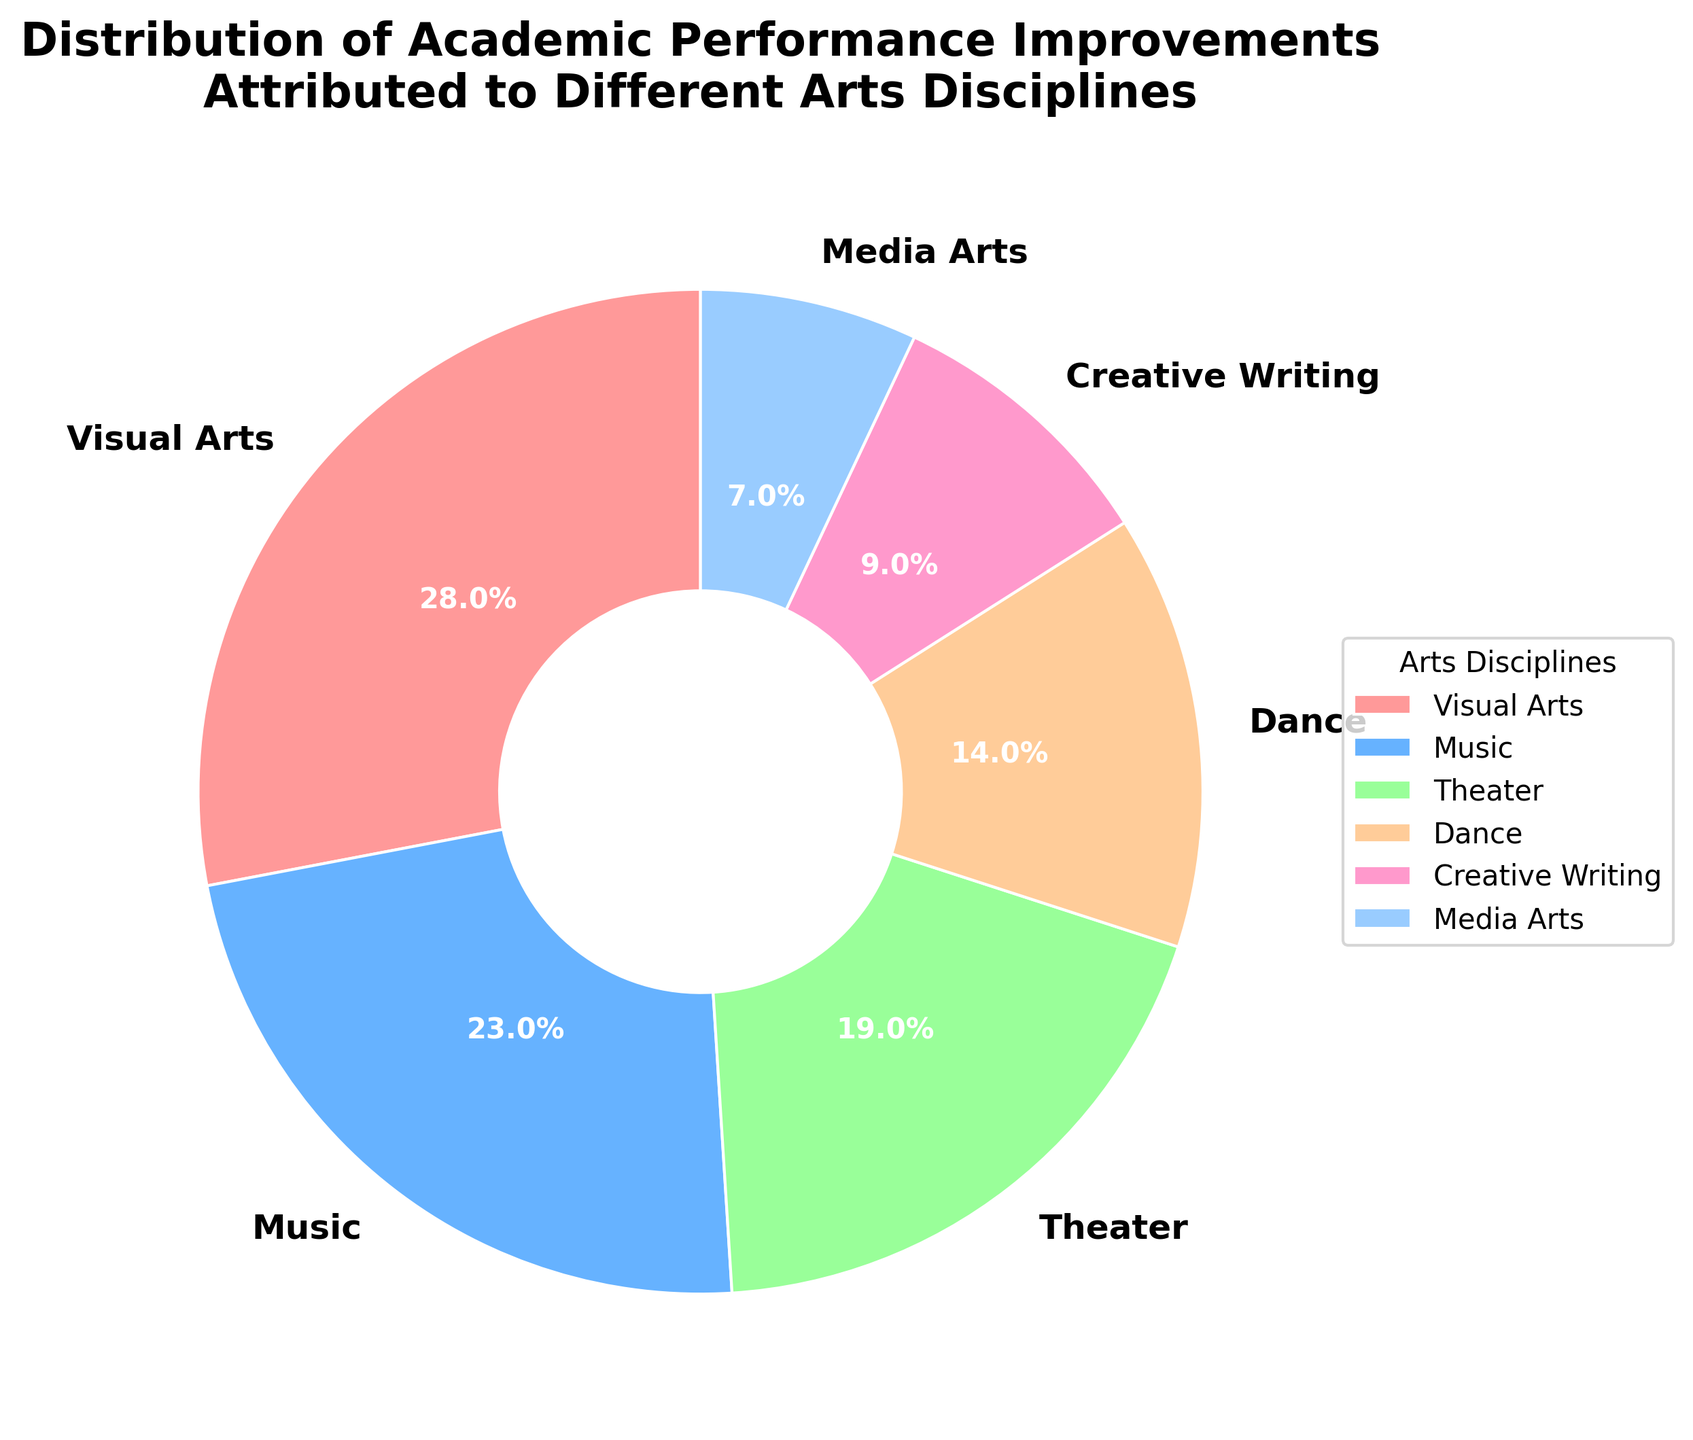What percentage of academic performance improvements is attributed to Visual Arts? Look at the segment labeled "Visual Arts" in the pie chart, which shows the percentage directly.
Answer: 28% Which two arts disciplines together contribute to the largest percentage of academic performance improvements? Identify the two largest segments in the pie chart and sum their percentages. Visual Arts and Music have the highest percentages at 28% and 23% respectively.
Answer: Visual Arts and Music How much more does Dance contribute compared to Media Arts? Subtract the percentage of Media Arts from the percentage of Dance. Dance contributes 14% and Media Arts contributes 7%, so 14% - 7% = 7%.
Answer: 7% Which arts discipline contributes the least to academic performance improvements? Identify the smallest segment in the pie chart, which is labeled with the smallest percentage.
Answer: Media Arts What is the combined contribution of Theater and Creative Writing to academic performance improvements? Add the percentages of Theater and Creative Writing. Theater is 19% and Creative Writing is 9%, so 19% + 9% = 28%.
Answer: 28% How does the contribution of Music compare to the contribution of Theater? Compare the percentages labeled for Music and Theater. Music contributes 23% and Theater contributes 19%, so Music contributes 4% more than Theater.
Answer: 4% more Which arts disciplines together make up more than 50% of the improvements? Sum the percentages until the total exceeds 50%. Visual Arts (28%) plus Music (23%) sum to 51%.
Answer: Visual Arts and Music What is the visual color representation for Creative Writing in the pie chart? Identify the color segment labeled "Creative Writing".
Answer: Light pink If the sum of contributions from Visual Arts, Music, and Theater is calculated, what percentage would that represent? Add the percentages of Visual Arts, Music, and Theater. Visual Arts is 28%, Music is 23%, and Theater is 19%, so 28% + 23% + 19% = 70%.
Answer: 70% Do Dance and Media Arts together contribute more than Creative Writing? Add the percentages of Dance and Media Arts and compare to Creative Writing. Dance is 14%, Media Arts is 7%, and Creative Writing is 9%. 14% + 7% = 21%, which is greater than 9%.
Answer: Yes 